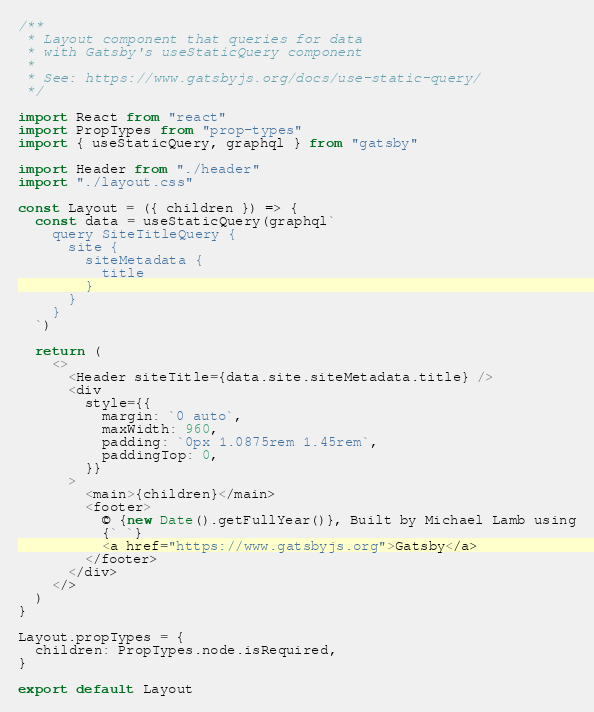Convert code to text. <code><loc_0><loc_0><loc_500><loc_500><_JavaScript_>/**
 * Layout component that queries for data
 * with Gatsby's useStaticQuery component
 *
 * See: https://www.gatsbyjs.org/docs/use-static-query/
 */

import React from "react"
import PropTypes from "prop-types"
import { useStaticQuery, graphql } from "gatsby"

import Header from "./header"
import "./layout.css"

const Layout = ({ children }) => {
  const data = useStaticQuery(graphql`
    query SiteTitleQuery {
      site {
        siteMetadata {
          title
        }
      }
    }
  `)

  return (
    <>
      <Header siteTitle={data.site.siteMetadata.title} />
      <div
        style={{
          margin: `0 auto`,
          maxWidth: 960,
          padding: `0px 1.0875rem 1.45rem`,
          paddingTop: 0,
        }}
      >
        <main>{children}</main>
        <footer>
          © {new Date().getFullYear()}, Built by Michael Lamb using
          {` `}
          <a href="https://www.gatsbyjs.org">Gatsby</a>
        </footer>
      </div>
    </>
  )
}

Layout.propTypes = {
  children: PropTypes.node.isRequired,
}

export default Layout
</code> 